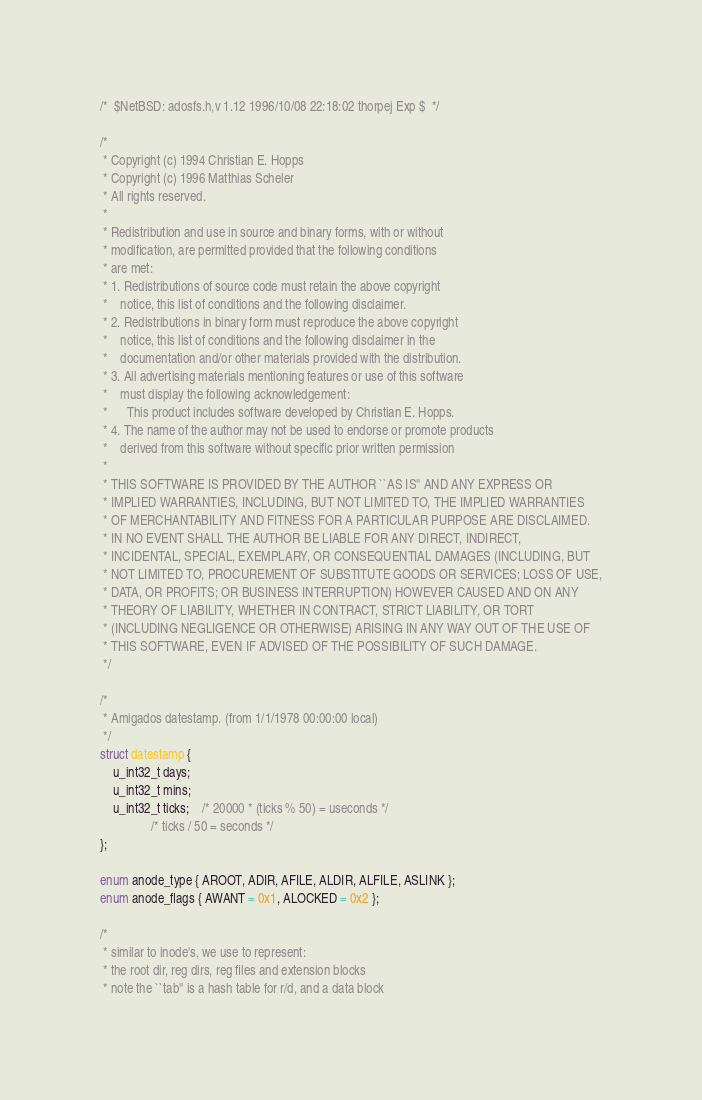Convert code to text. <code><loc_0><loc_0><loc_500><loc_500><_C_>/*	$NetBSD: adosfs.h,v 1.12 1996/10/08 22:18:02 thorpej Exp $	*/

/*
 * Copyright (c) 1994 Christian E. Hopps
 * Copyright (c) 1996 Matthias Scheler
 * All rights reserved.
 *
 * Redistribution and use in source and binary forms, with or without
 * modification, are permitted provided that the following conditions
 * are met:
 * 1. Redistributions of source code must retain the above copyright
 *    notice, this list of conditions and the following disclaimer.
 * 2. Redistributions in binary form must reproduce the above copyright
 *    notice, this list of conditions and the following disclaimer in the
 *    documentation and/or other materials provided with the distribution.
 * 3. All advertising materials mentioning features or use of this software
 *    must display the following acknowledgement:
 *      This product includes software developed by Christian E. Hopps.
 * 4. The name of the author may not be used to endorse or promote products
 *    derived from this software without specific prior written permission
 *
 * THIS SOFTWARE IS PROVIDED BY THE AUTHOR ``AS IS'' AND ANY EXPRESS OR
 * IMPLIED WARRANTIES, INCLUDING, BUT NOT LIMITED TO, THE IMPLIED WARRANTIES
 * OF MERCHANTABILITY AND FITNESS FOR A PARTICULAR PURPOSE ARE DISCLAIMED.
 * IN NO EVENT SHALL THE AUTHOR BE LIABLE FOR ANY DIRECT, INDIRECT,
 * INCIDENTAL, SPECIAL, EXEMPLARY, OR CONSEQUENTIAL DAMAGES (INCLUDING, BUT
 * NOT LIMITED TO, PROCUREMENT OF SUBSTITUTE GOODS OR SERVICES; LOSS OF USE,
 * DATA, OR PROFITS; OR BUSINESS INTERRUPTION) HOWEVER CAUSED AND ON ANY
 * THEORY OF LIABILITY, WHETHER IN CONTRACT, STRICT LIABILITY, OR TORT
 * (INCLUDING NEGLIGENCE OR OTHERWISE) ARISING IN ANY WAY OUT OF THE USE OF
 * THIS SOFTWARE, EVEN IF ADVISED OF THE POSSIBILITY OF SUCH DAMAGE.
 */

/*
 * Amigados datestamp. (from 1/1/1978 00:00:00 local)
 */
struct datestamp {
	u_int32_t days;
	u_int32_t mins;
	u_int32_t ticks;	/* 20000 * (ticks % 50) = useconds */
				/* ticks / 50 = seconds */
};

enum anode_type { AROOT, ADIR, AFILE, ALDIR, ALFILE, ASLINK };
enum anode_flags { AWANT = 0x1, ALOCKED = 0x2 };

/* 
 * similar to inode's, we use to represent:
 * the root dir, reg dirs, reg files and extension blocks
 * note the ``tab'' is a hash table for r/d, and a data block</code> 